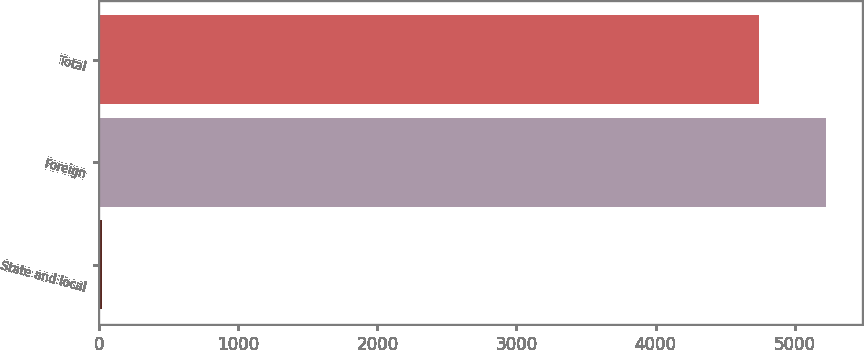Convert chart to OTSL. <chart><loc_0><loc_0><loc_500><loc_500><bar_chart><fcel>State and local<fcel>Foreign<fcel>Total<nl><fcel>23<fcel>5223.1<fcel>4741<nl></chart> 